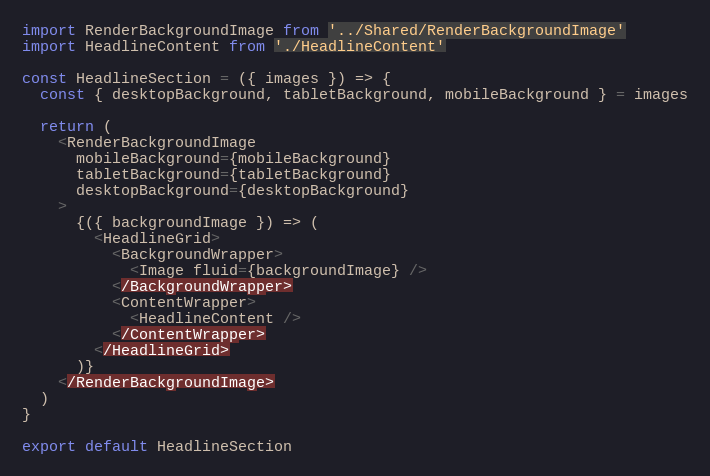<code> <loc_0><loc_0><loc_500><loc_500><_JavaScript_>import RenderBackgroundImage from '../Shared/RenderBackgroundImage'
import HeadlineContent from './HeadlineContent'

const HeadlineSection = ({ images }) => {
  const { desktopBackground, tabletBackground, mobileBackground } = images

  return (
    <RenderBackgroundImage
      mobileBackground={mobileBackground}
      tabletBackground={tabletBackground}
      desktopBackground={desktopBackground}
    >
      {({ backgroundImage }) => (
        <HeadlineGrid>
          <BackgroundWrapper>
            <Image fluid={backgroundImage} />
          </BackgroundWrapper>
          <ContentWrapper>
            <HeadlineContent />
          </ContentWrapper>
        </HeadlineGrid>
      )}
    </RenderBackgroundImage>
  )
}

export default HeadlineSection
</code> 